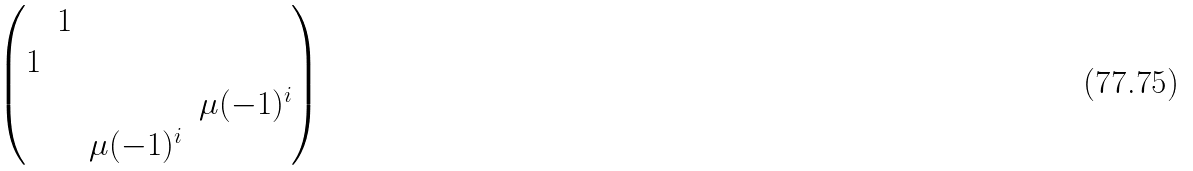Convert formula to latex. <formula><loc_0><loc_0><loc_500><loc_500>\begin{pmatrix} & 1 & & \\ 1 & & & \\ & & & \mu ( - 1 ) ^ { i } \\ & & \mu ( - 1 ) ^ { i } & \end{pmatrix}</formula> 